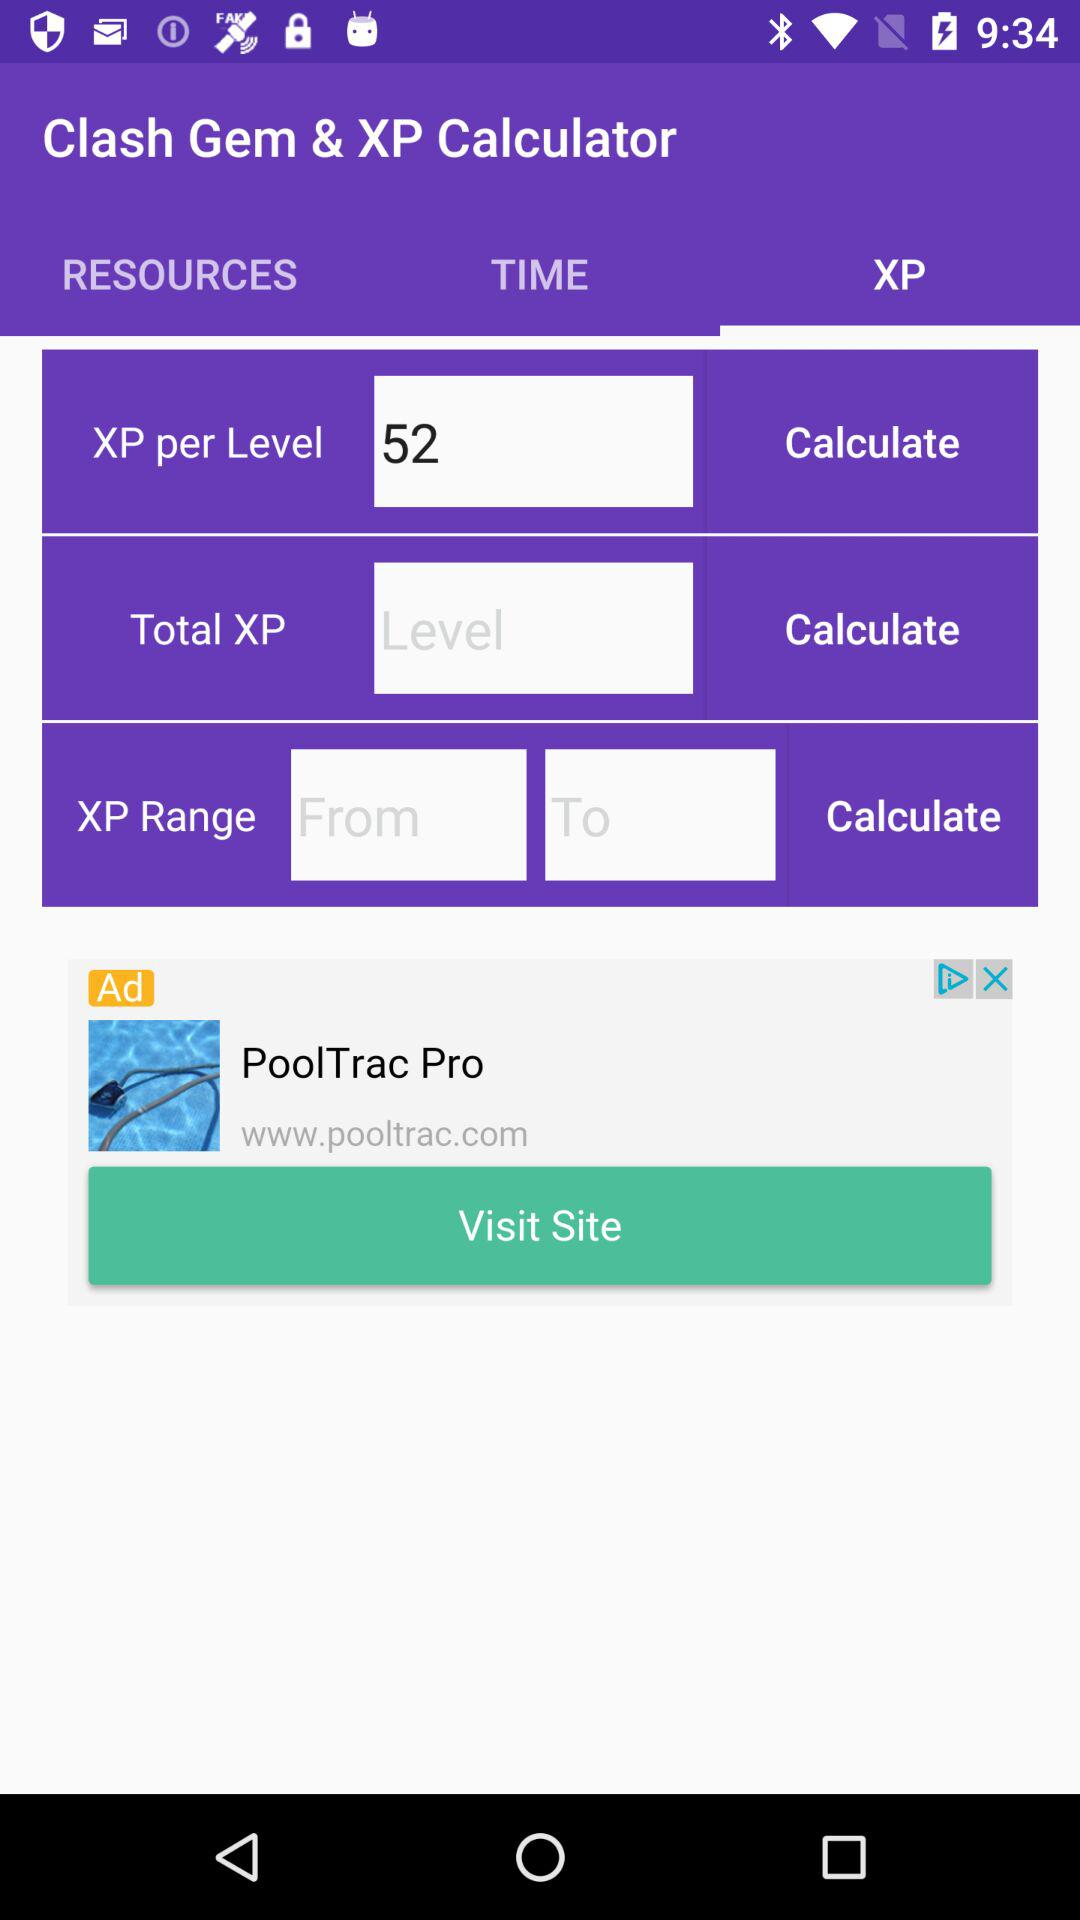Which tab is selected? The selected tab is "XP". 